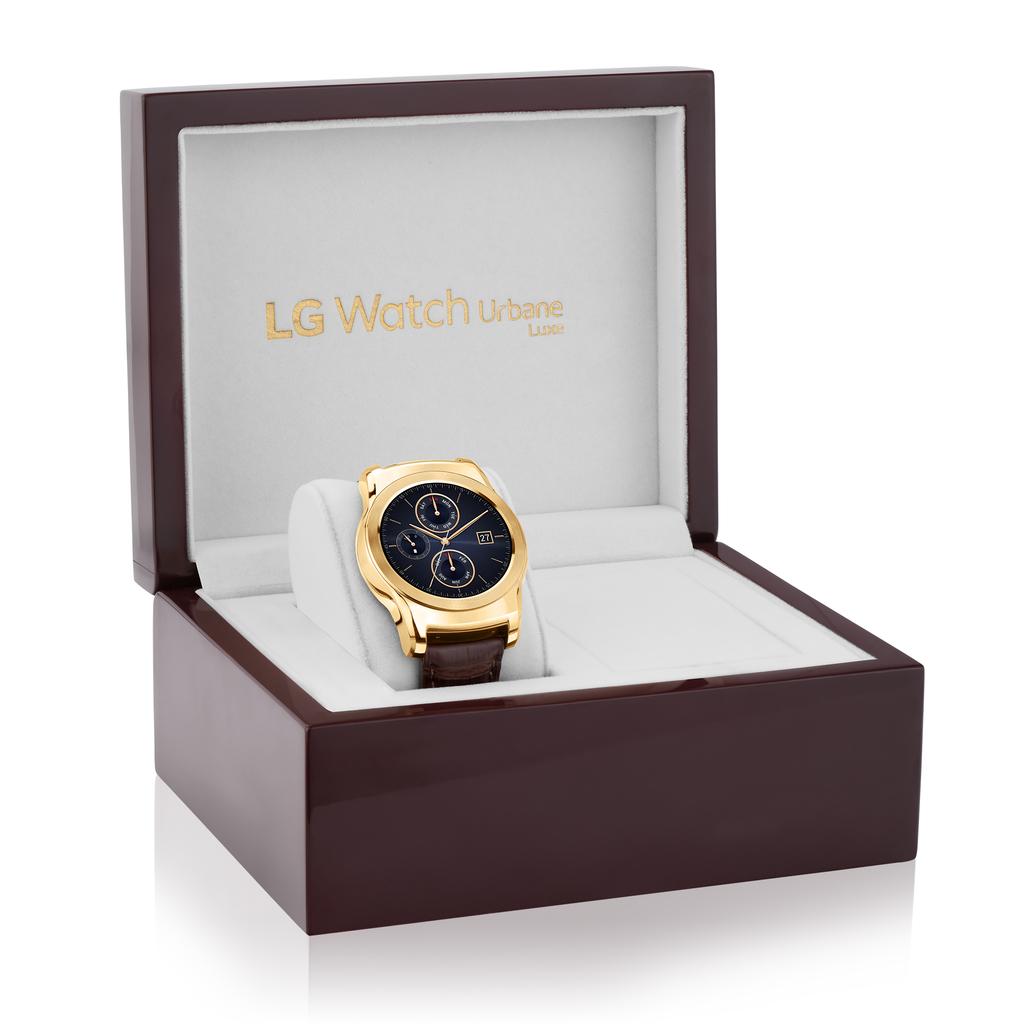What brand of watch is this?
Provide a succinct answer. Lg. What company produced this watch?
Provide a short and direct response. Lg. 